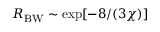<formula> <loc_0><loc_0><loc_500><loc_500>R _ { B W } \sim \exp [ - 8 / ( 3 \chi ) ]</formula> 